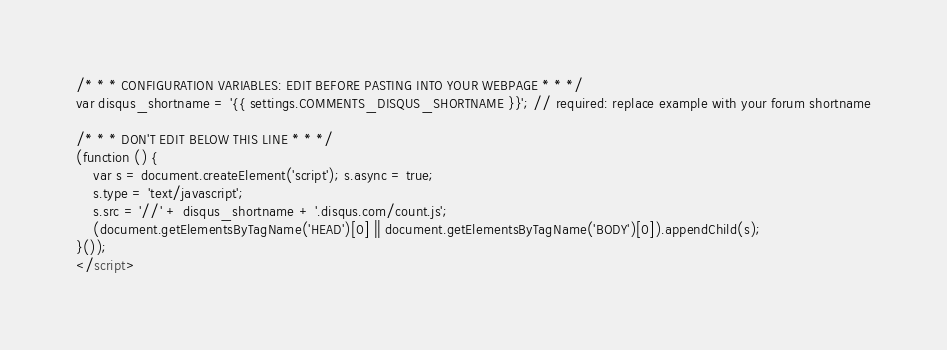<code> <loc_0><loc_0><loc_500><loc_500><_HTML_>/* * * CONFIGURATION VARIABLES: EDIT BEFORE PASTING INTO YOUR WEBPAGE * * */
var disqus_shortname = '{{ settings.COMMENTS_DISQUS_SHORTNAME }}'; // required: replace example with your forum shortname

/* * * DON'T EDIT BELOW THIS LINE * * */
(function () {
    var s = document.createElement('script'); s.async = true;
    s.type = 'text/javascript';
    s.src = '//' + disqus_shortname + '.disqus.com/count.js';
    (document.getElementsByTagName('HEAD')[0] || document.getElementsByTagName('BODY')[0]).appendChild(s);
}());
</script>
</code> 